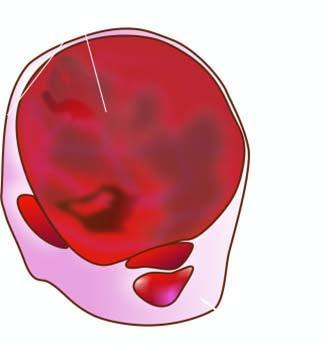what does cut section show?
Answer the question using a single word or phrase. Lobules of translucent gelatinous light brown parenchyma and areas of haemorrhage 